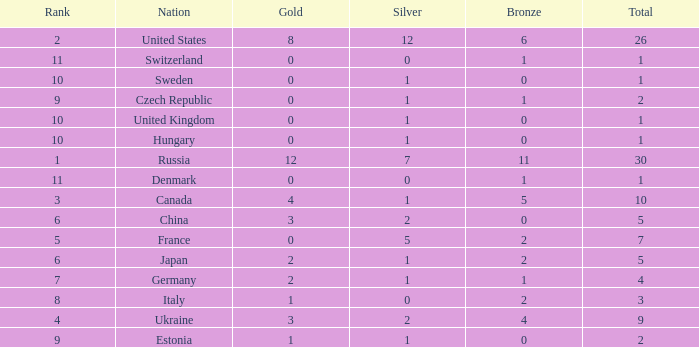How many silvers have a Nation of hungary, and a Rank larger than 10? 0.0. 